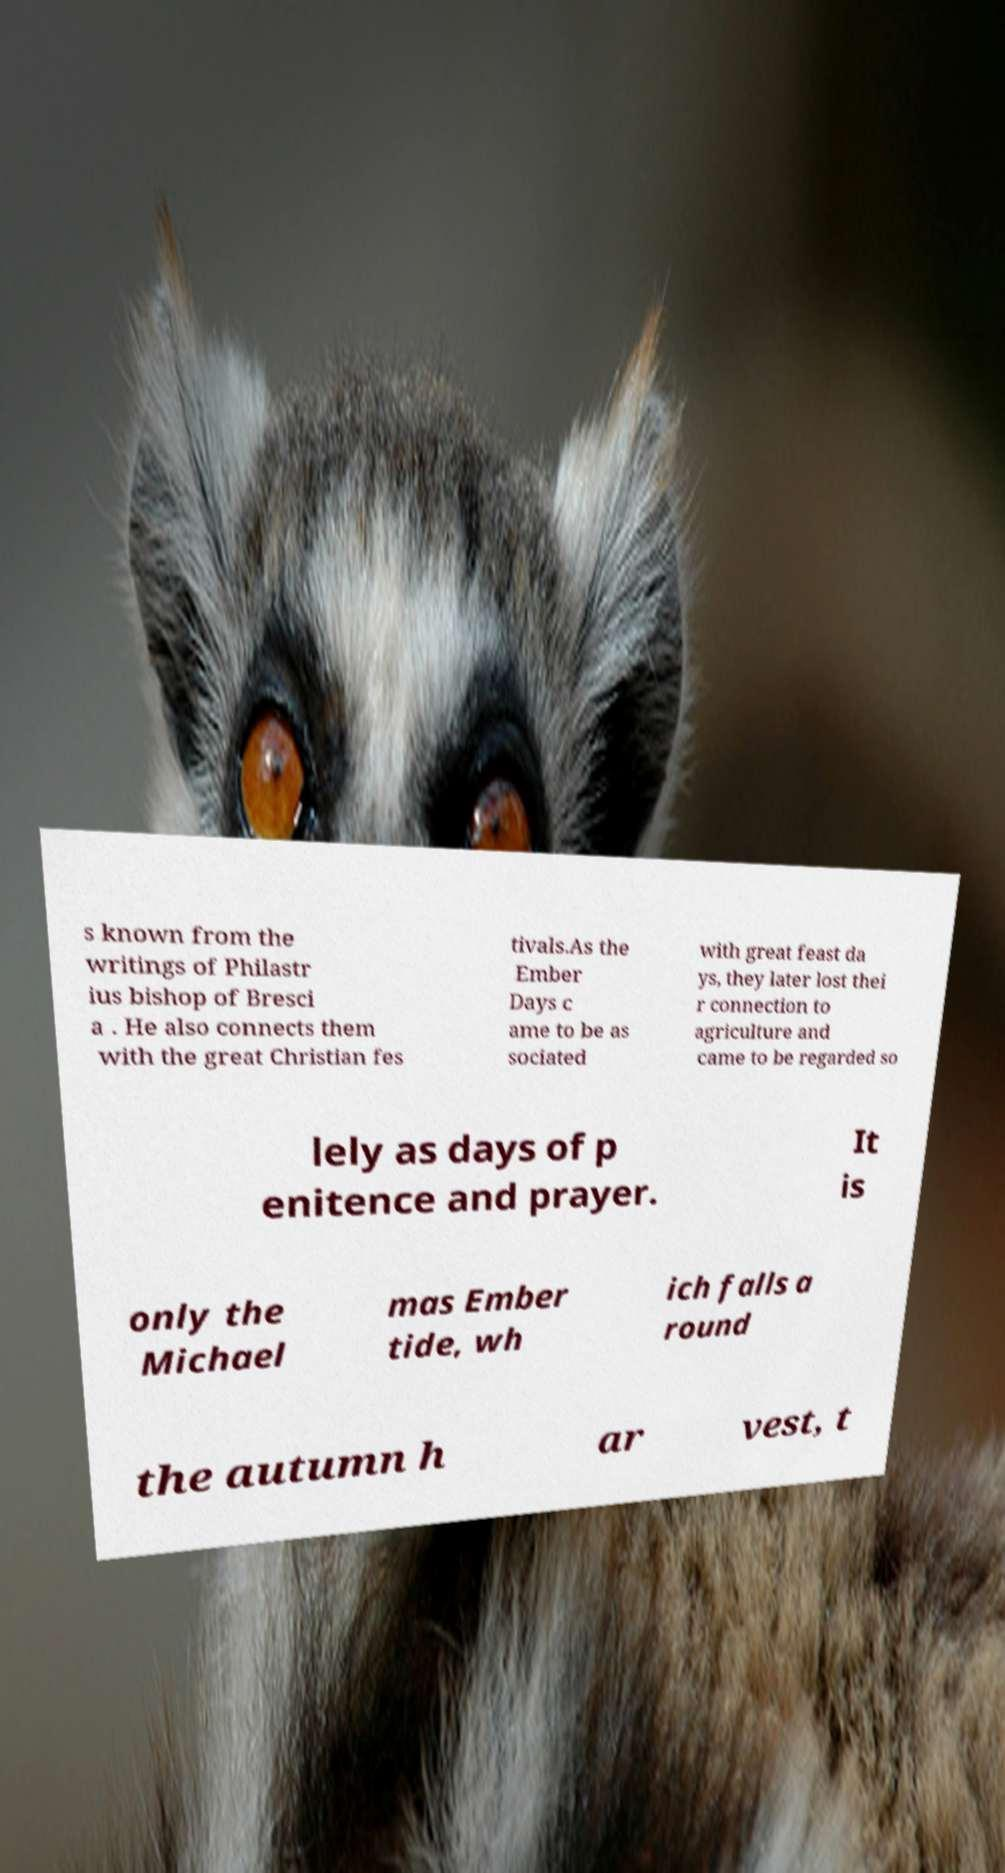I need the written content from this picture converted into text. Can you do that? s known from the writings of Philastr ius bishop of Bresci a . He also connects them with the great Christian fes tivals.As the Ember Days c ame to be as sociated with great feast da ys, they later lost thei r connection to agriculture and came to be regarded so lely as days of p enitence and prayer. It is only the Michael mas Ember tide, wh ich falls a round the autumn h ar vest, t 